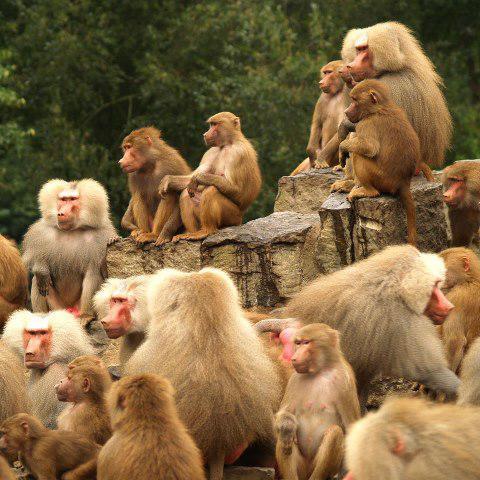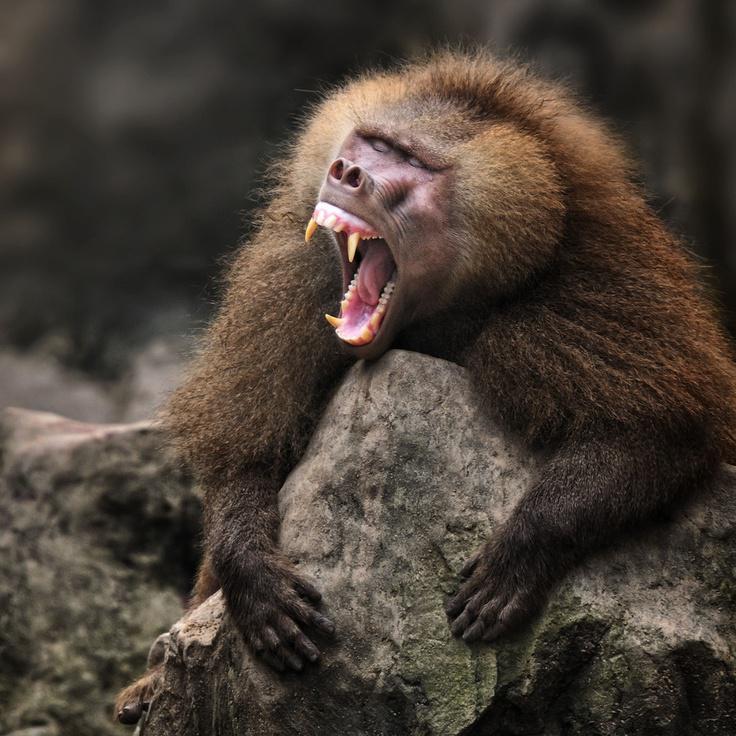The first image is the image on the left, the second image is the image on the right. Analyze the images presented: Is the assertion "Humorous memes about baboons" valid? Answer yes or no. No. 